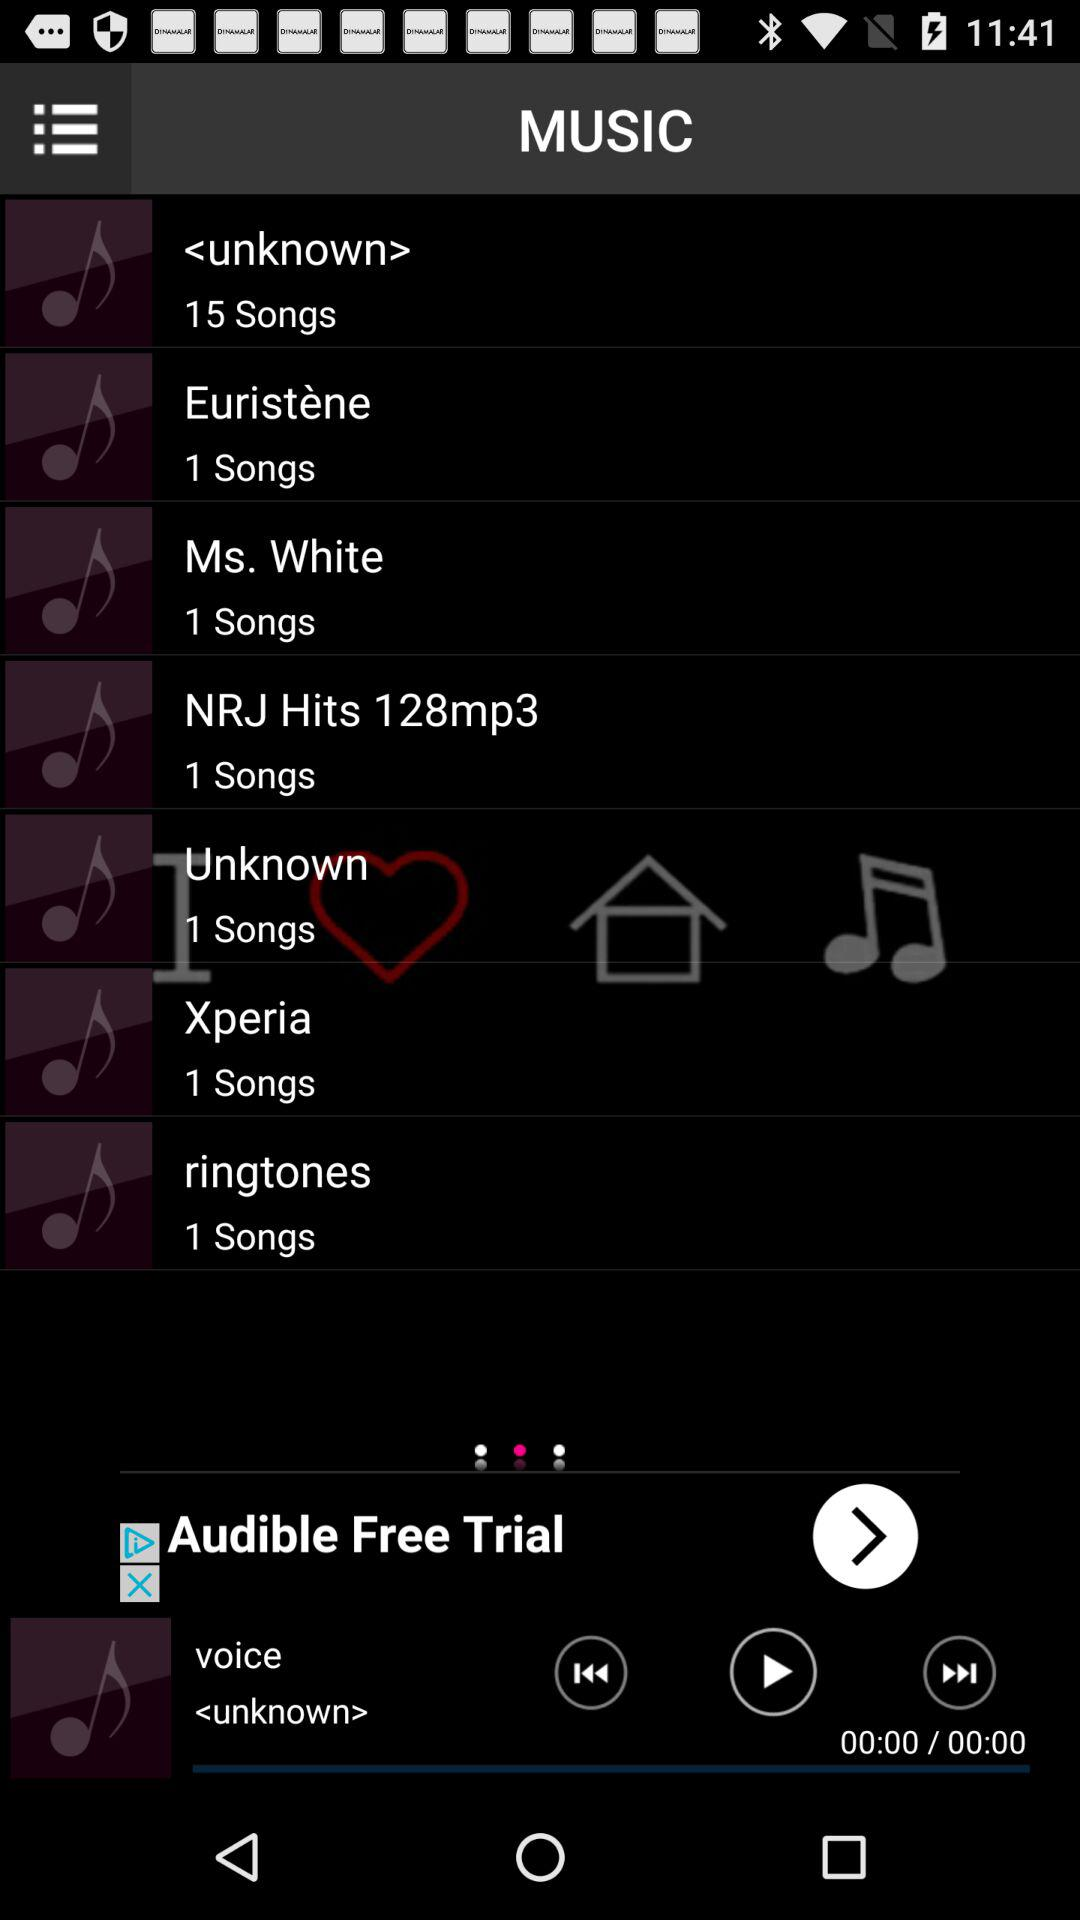How many songs are there in the "ringtones" album? There is 1 song in "ringtones" album. 